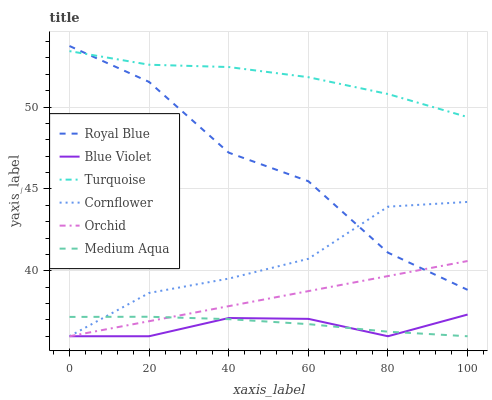Does Blue Violet have the minimum area under the curve?
Answer yes or no. Yes. Does Turquoise have the maximum area under the curve?
Answer yes or no. Yes. Does Royal Blue have the minimum area under the curve?
Answer yes or no. No. Does Royal Blue have the maximum area under the curve?
Answer yes or no. No. Is Orchid the smoothest?
Answer yes or no. Yes. Is Royal Blue the roughest?
Answer yes or no. Yes. Is Turquoise the smoothest?
Answer yes or no. No. Is Turquoise the roughest?
Answer yes or no. No. Does Cornflower have the lowest value?
Answer yes or no. Yes. Does Royal Blue have the lowest value?
Answer yes or no. No. Does Royal Blue have the highest value?
Answer yes or no. Yes. Does Turquoise have the highest value?
Answer yes or no. No. Is Orchid less than Turquoise?
Answer yes or no. Yes. Is Royal Blue greater than Blue Violet?
Answer yes or no. Yes. Does Orchid intersect Medium Aqua?
Answer yes or no. Yes. Is Orchid less than Medium Aqua?
Answer yes or no. No. Is Orchid greater than Medium Aqua?
Answer yes or no. No. Does Orchid intersect Turquoise?
Answer yes or no. No. 